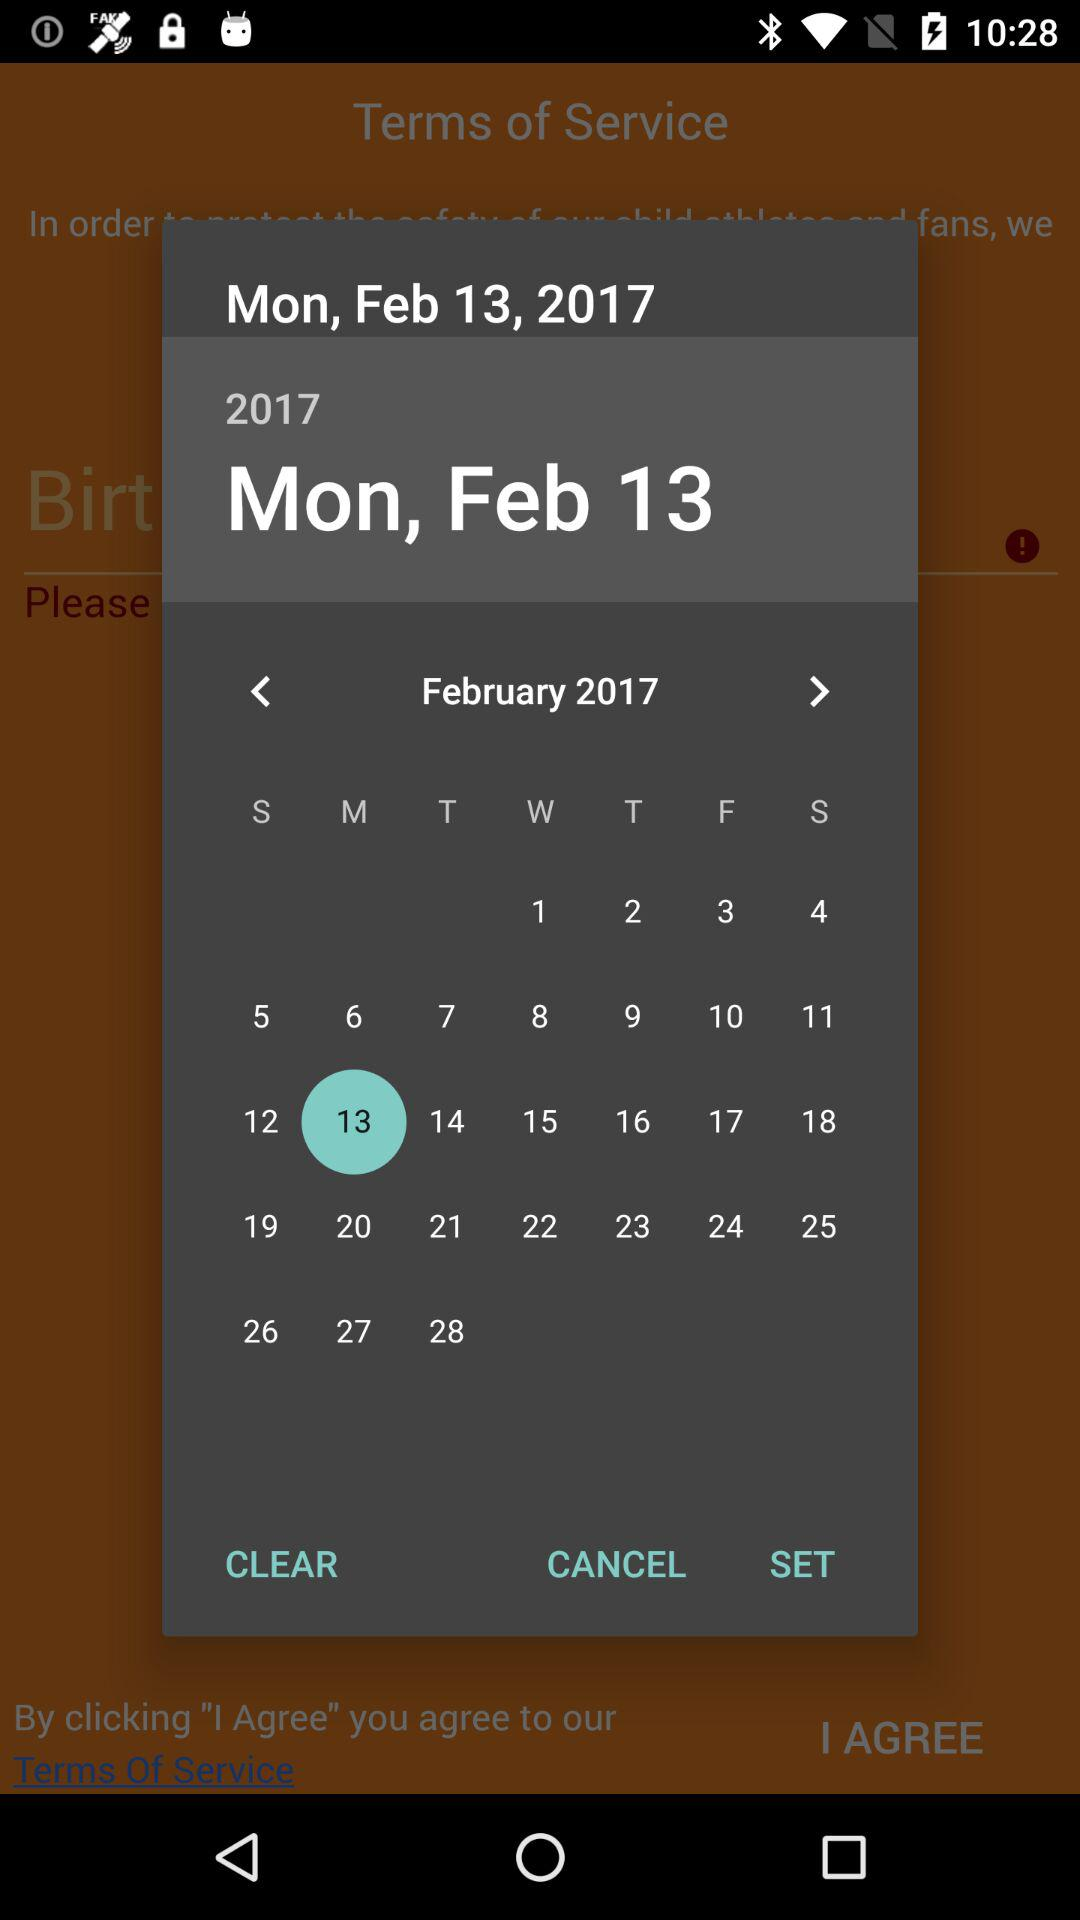Which year has been selected? The year 2017 has been selected. 